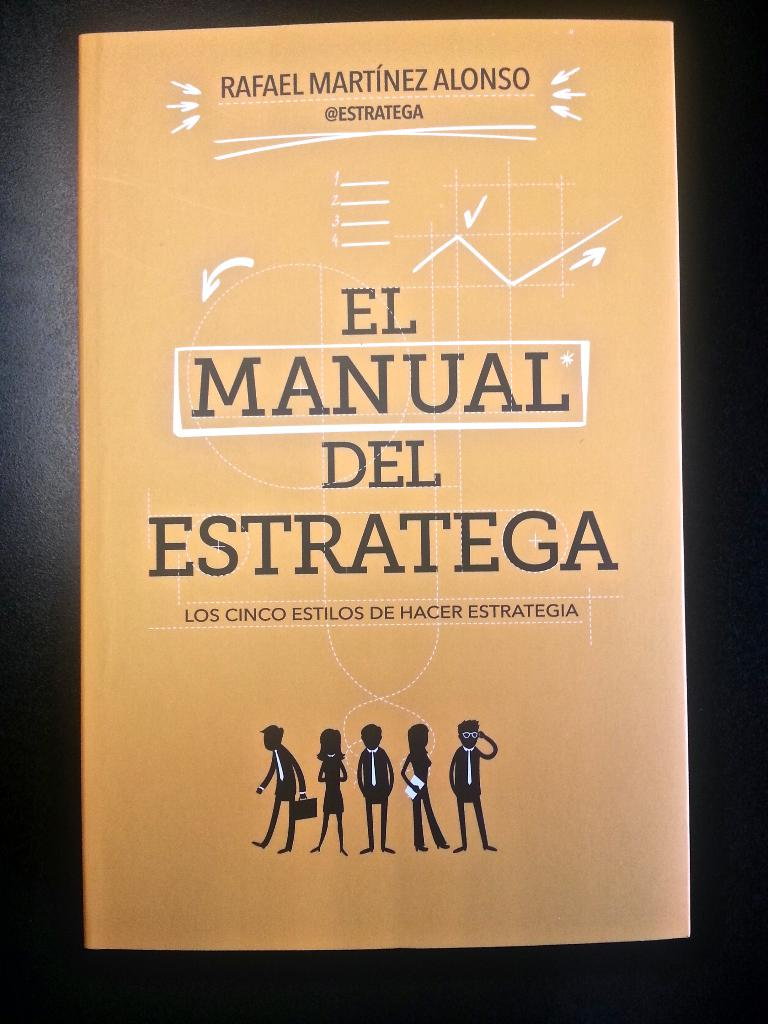What do you see happening in this image? The image showcases the cover of 'El Manual del Estratega' by Rafael Martínez Alonso, an engaging guide on strategic thinking. The bright orange cover features a crisp and clear white text for both the title and the author’s name, accompanied below by the intriguing subtitle, 'Los Cinco Estilos De Hacer Estrategia,' hinting at the exploration of five distinct strategic styles. The cover art includes silhouettes of five figures, each styled differently from the next, likely symbolizing the diversity in strategic approaches discussed within. Also, the inclusion of the author’s Twitter handle '@Estratega' not only suggests his active online engagement, but also invites readers to join a broader conversation about strategies in modern contexts. This cover combines visual simplicity with depth, suggesting a book that's accessible yet rich with insights on effective strategizing. 